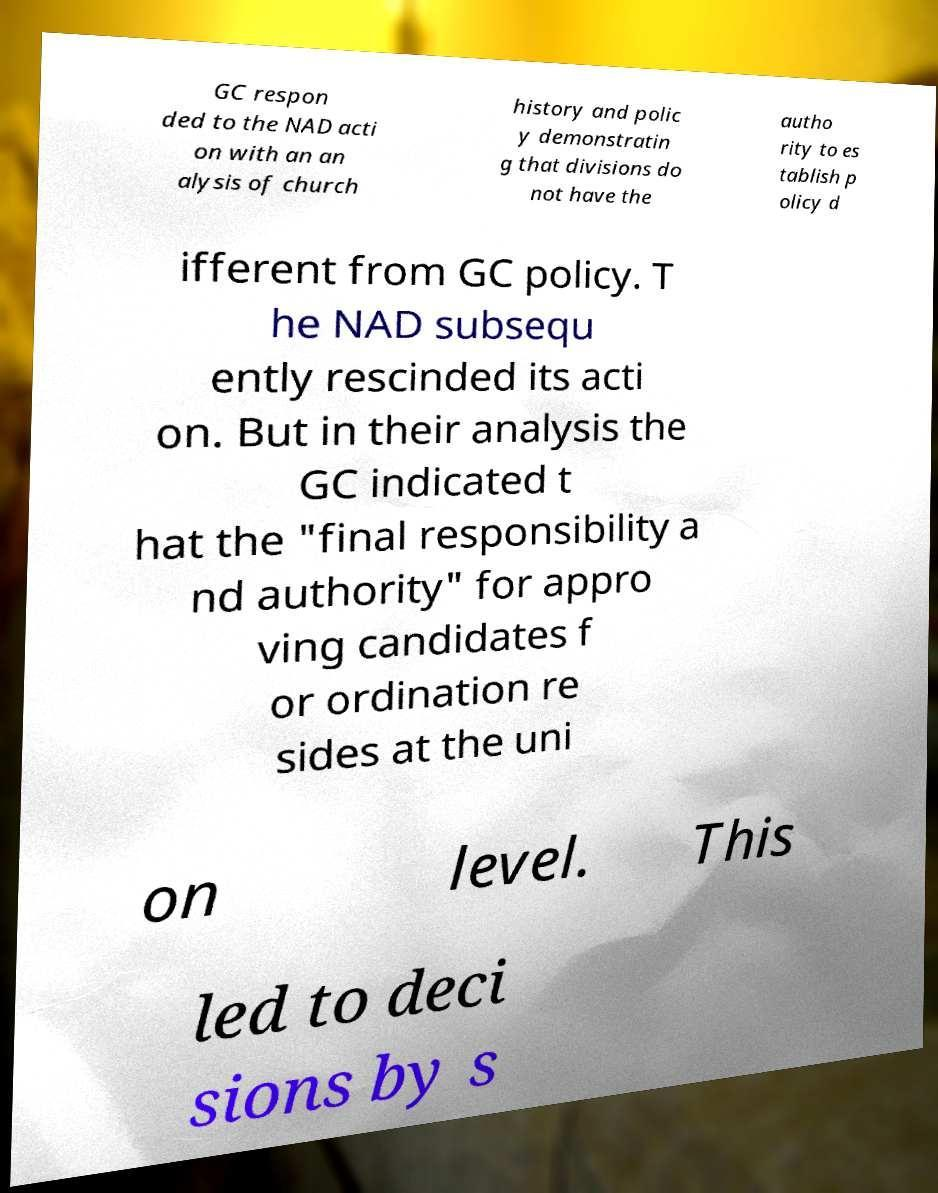For documentation purposes, I need the text within this image transcribed. Could you provide that? GC respon ded to the NAD acti on with an an alysis of church history and polic y demonstratin g that divisions do not have the autho rity to es tablish p olicy d ifferent from GC policy. T he NAD subsequ ently rescinded its acti on. But in their analysis the GC indicated t hat the "final responsibility a nd authority" for appro ving candidates f or ordination re sides at the uni on level. This led to deci sions by s 